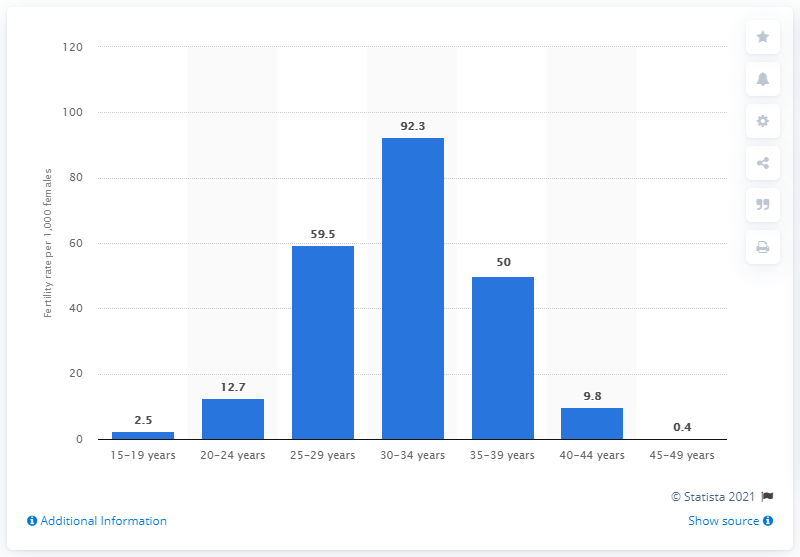Give some essential details in this illustration. In 2019, the fertility rate for Singaporean females between the ages of 30 and 34 was 92.3%. 